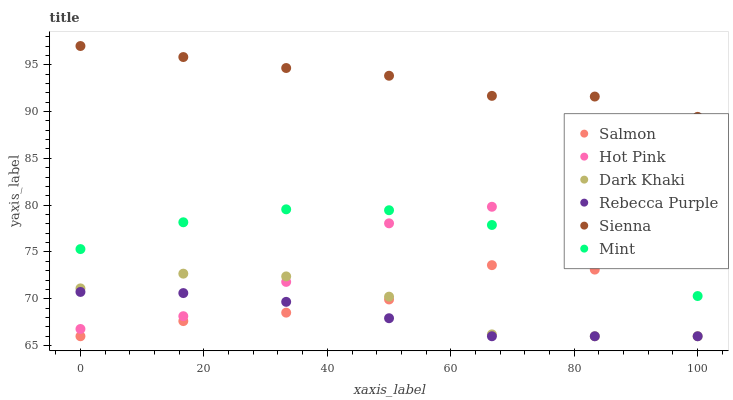Does Rebecca Purple have the minimum area under the curve?
Answer yes or no. Yes. Does Sienna have the maximum area under the curve?
Answer yes or no. Yes. Does Hot Pink have the minimum area under the curve?
Answer yes or no. No. Does Hot Pink have the maximum area under the curve?
Answer yes or no. No. Is Rebecca Purple the smoothest?
Answer yes or no. Yes. Is Hot Pink the roughest?
Answer yes or no. Yes. Is Salmon the smoothest?
Answer yes or no. No. Is Salmon the roughest?
Answer yes or no. No. Does Salmon have the lowest value?
Answer yes or no. Yes. Does Hot Pink have the lowest value?
Answer yes or no. No. Does Sienna have the highest value?
Answer yes or no. Yes. Does Hot Pink have the highest value?
Answer yes or no. No. Is Salmon less than Sienna?
Answer yes or no. Yes. Is Sienna greater than Rebecca Purple?
Answer yes or no. Yes. Does Hot Pink intersect Dark Khaki?
Answer yes or no. Yes. Is Hot Pink less than Dark Khaki?
Answer yes or no. No. Is Hot Pink greater than Dark Khaki?
Answer yes or no. No. Does Salmon intersect Sienna?
Answer yes or no. No. 